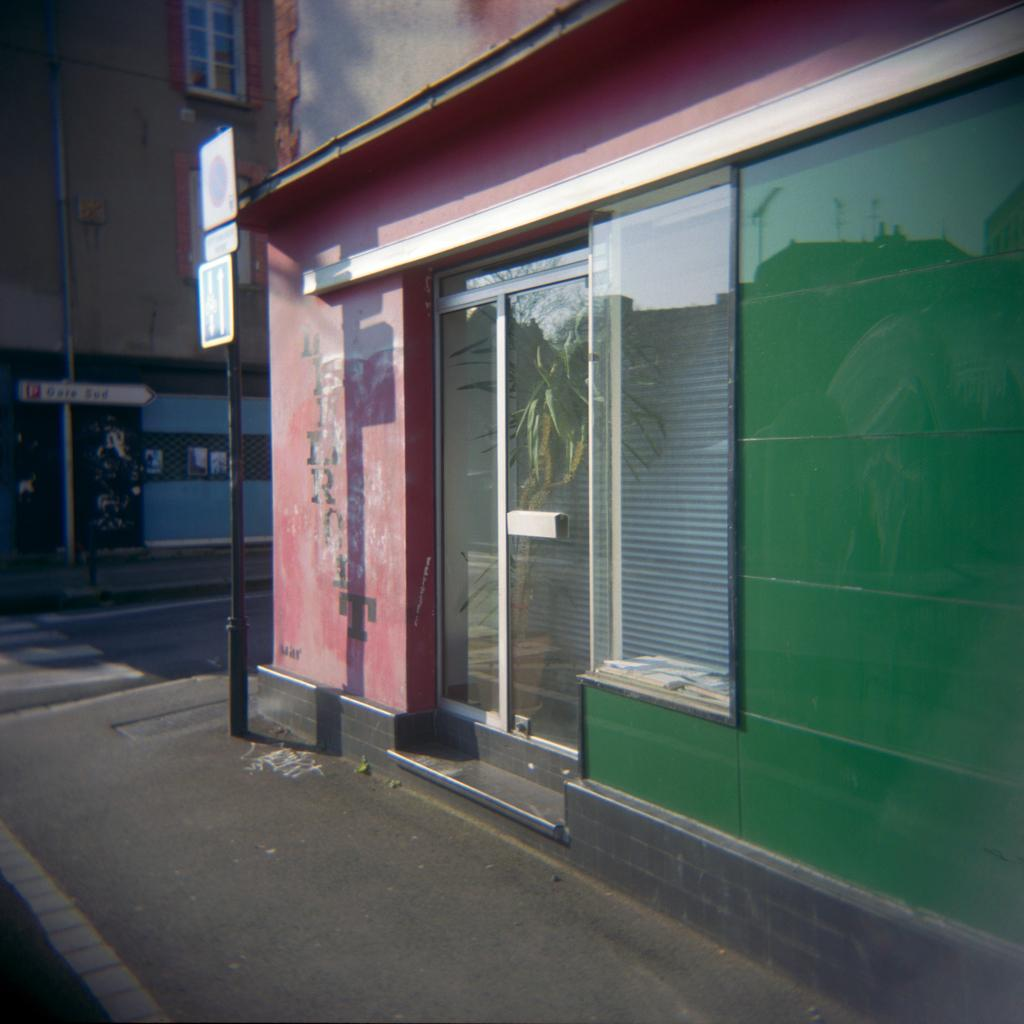What type of surface can be seen in the image? There is a sidewalk and a road in the image. What structure is present in the image? There is a pole in the image. What type of construction is visible in the image? There are boards and buildings in the image. What architectural features can be seen in the image? There is a window and a glass door in the image. What natural element is visible through the window and glass door? A tree is visible through the window and glass door. What type of ink is being used to write on the boards in the image? There is no indication in the image that any writing is taking place on the boards, and therefore no ink can be observed. 